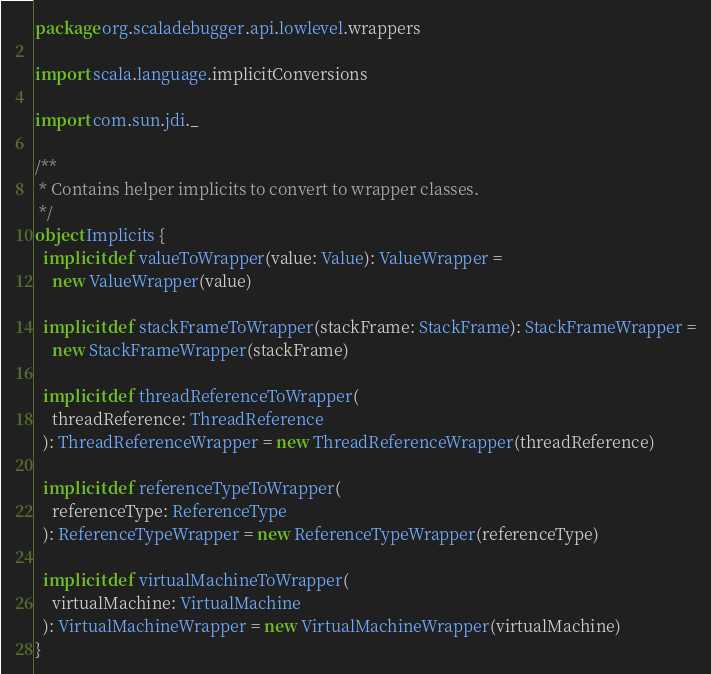<code> <loc_0><loc_0><loc_500><loc_500><_Scala_>package org.scaladebugger.api.lowlevel.wrappers

import scala.language.implicitConversions

import com.sun.jdi._

/**
 * Contains helper implicits to convert to wrapper classes.
 */
object Implicits {
  implicit def valueToWrapper(value: Value): ValueWrapper =
    new ValueWrapper(value)

  implicit def stackFrameToWrapper(stackFrame: StackFrame): StackFrameWrapper =
    new StackFrameWrapper(stackFrame)

  implicit def threadReferenceToWrapper(
    threadReference: ThreadReference
  ): ThreadReferenceWrapper = new ThreadReferenceWrapper(threadReference)

  implicit def referenceTypeToWrapper(
    referenceType: ReferenceType
  ): ReferenceTypeWrapper = new ReferenceTypeWrapper(referenceType)

  implicit def virtualMachineToWrapper(
    virtualMachine: VirtualMachine
  ): VirtualMachineWrapper = new VirtualMachineWrapper(virtualMachine)
}
</code> 